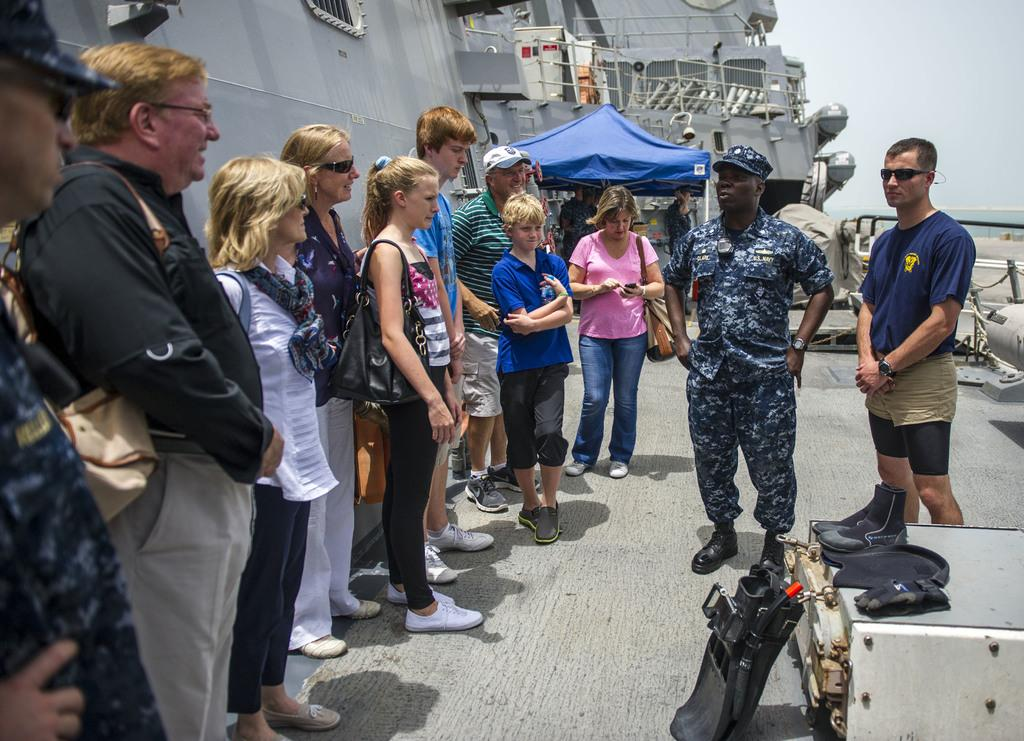How many people are in the group visible in the image? There is a group of people in the image, but the exact number is not specified. What type of structure is present in the image? There is a stall in the image. What else can be seen in the image besides the group of people and the stall? There are other items in the image. Where does the scene take place? The scene takes place on a ship. What is the ship's location in relation to the water? The ship is on water. What can be seen in the background of the image? The sky is visible in the background of the image. What type of spot is visible on the ship in the image? There is no mention of a spot on the ship in the image. What type of journey is the group of people taking in the image? The image does not provide information about the group's journey or destination. 